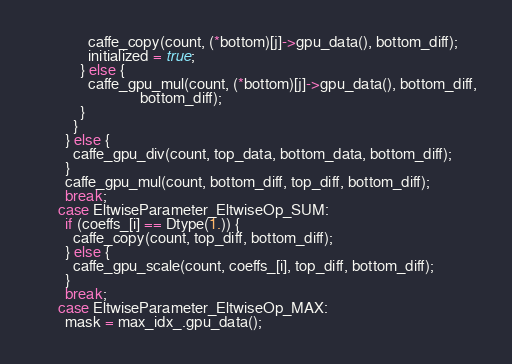<code> <loc_0><loc_0><loc_500><loc_500><_Cuda_>              caffe_copy(count, (*bottom)[j]->gpu_data(), bottom_diff);
              initialized = true;
            } else {
              caffe_gpu_mul(count, (*bottom)[j]->gpu_data(), bottom_diff,
                            bottom_diff);
            }
          }
        } else {
          caffe_gpu_div(count, top_data, bottom_data, bottom_diff);
        }
        caffe_gpu_mul(count, bottom_diff, top_diff, bottom_diff);
        break;
      case EltwiseParameter_EltwiseOp_SUM:
        if (coeffs_[i] == Dtype(1.)) {
          caffe_copy(count, top_diff, bottom_diff);
        } else {
          caffe_gpu_scale(count, coeffs_[i], top_diff, bottom_diff);
        }
        break;
      case EltwiseParameter_EltwiseOp_MAX:
        mask = max_idx_.gpu_data();</code> 